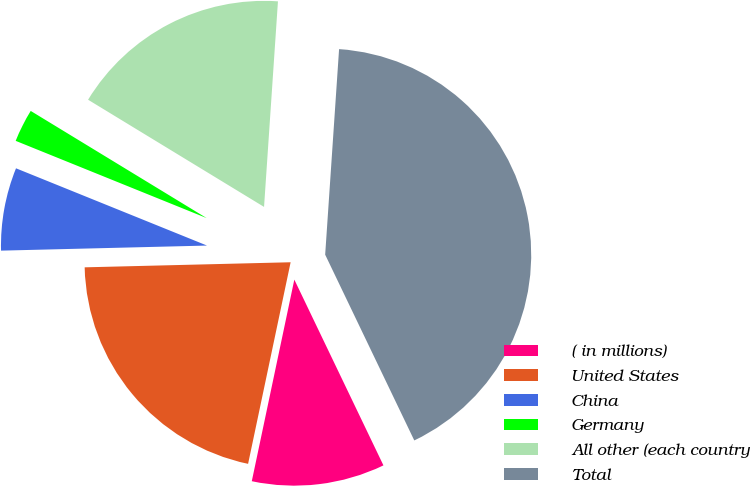<chart> <loc_0><loc_0><loc_500><loc_500><pie_chart><fcel>( in millions)<fcel>United States<fcel>China<fcel>Germany<fcel>All other (each country<fcel>Total<nl><fcel>10.43%<fcel>21.3%<fcel>6.51%<fcel>2.59%<fcel>17.37%<fcel>41.81%<nl></chart> 